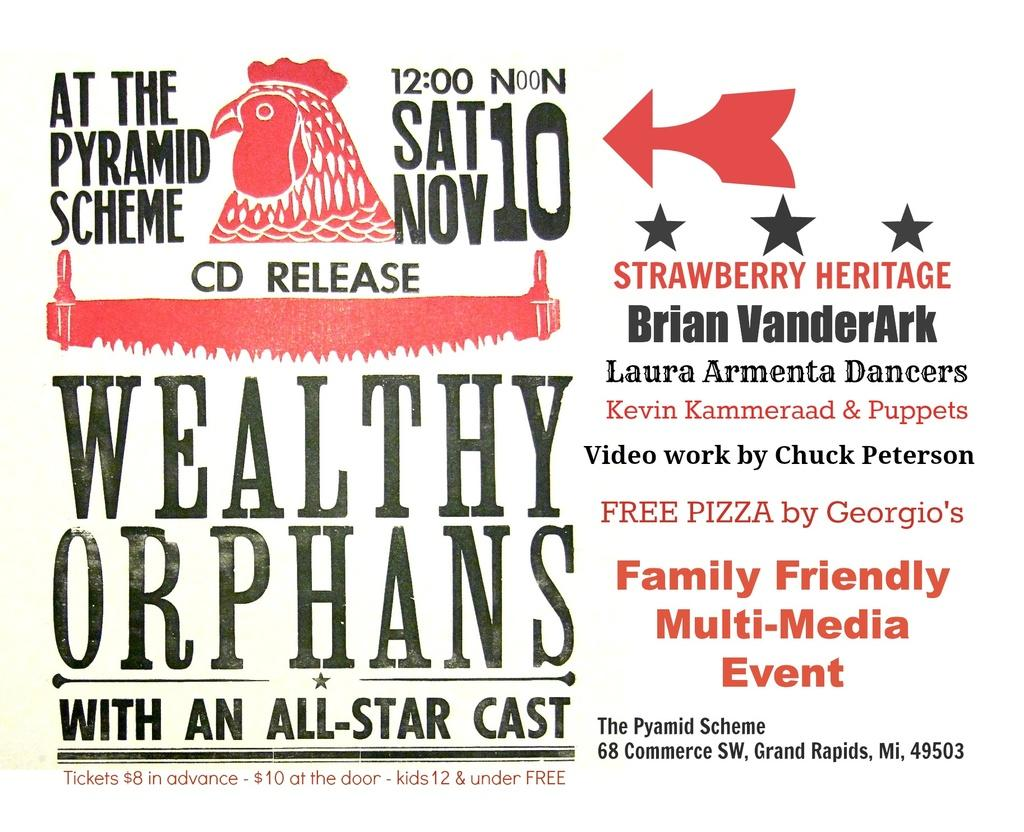What is the main object in the image? There is a magazine in the image. What is the name of the magazine? The magazine has the name "Wealthy Orphans" on it. Are there any additional wordings on the magazine? Yes, there are wordings beside the name on the magazine. Can you tell me where the nearest airport is mentioned in the image? There is no mention of an airport in the image; it only features a magazine with the name "Wealthy Orphans" and additional wordings. 